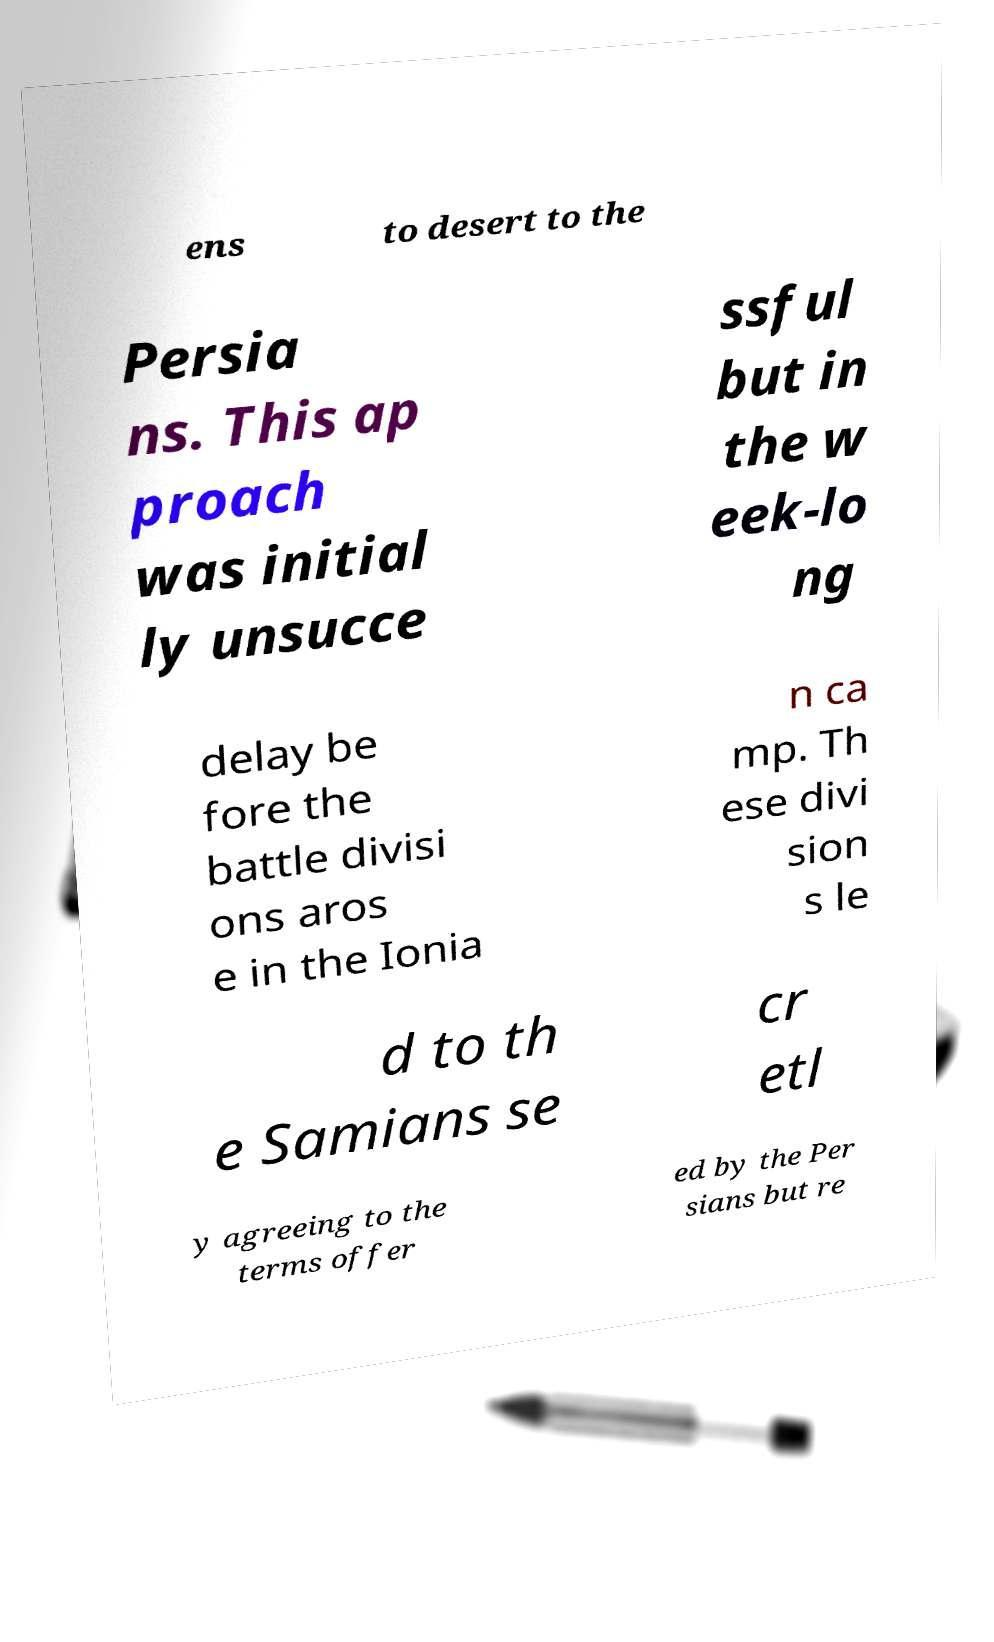Can you read and provide the text displayed in the image?This photo seems to have some interesting text. Can you extract and type it out for me? ens to desert to the Persia ns. This ap proach was initial ly unsucce ssful but in the w eek-lo ng delay be fore the battle divisi ons aros e in the Ionia n ca mp. Th ese divi sion s le d to th e Samians se cr etl y agreeing to the terms offer ed by the Per sians but re 